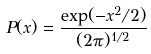Convert formula to latex. <formula><loc_0><loc_0><loc_500><loc_500>P ( x ) = \frac { \exp ( - x ^ { 2 } / 2 ) } { ( 2 \pi ) ^ { 1 / 2 } }</formula> 